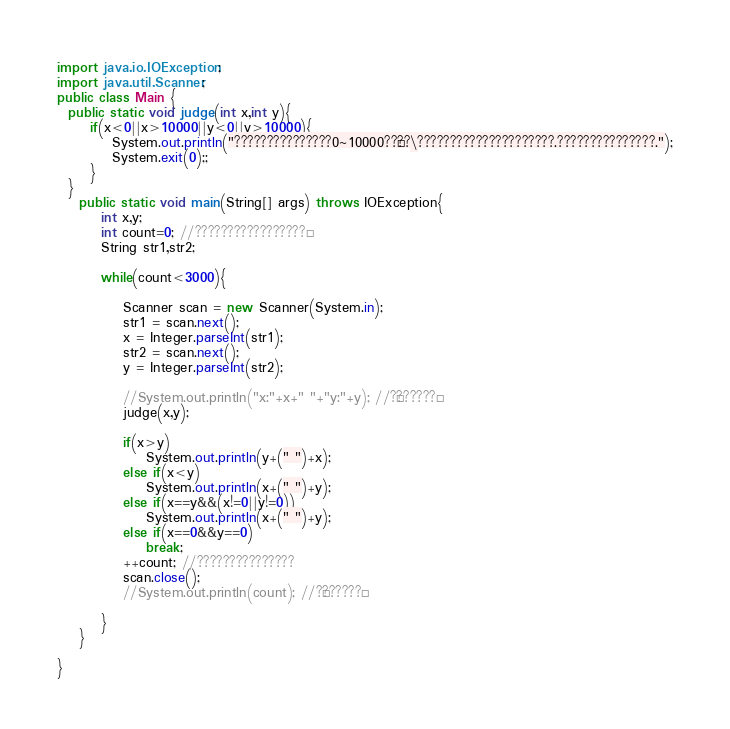Convert code to text. <code><loc_0><loc_0><loc_500><loc_500><_Java_>import java.io.IOException;
import java.util.Scanner;
public class Main {
  public static void judge(int x,int y){
	  if(x<0||x>10000||y<0||y>10000){
		  System.out.println("???????????????0~10000??§??\?????????????????????.???????????????.");
	      System.exit(0);;
	  }
  }
	public static void main(String[] args) throws IOException{
		int x,y;
		int count=0; //?????????????????°
		String str1,str2;

		while(count<3000){

			Scanner scan = new Scanner(System.in);
			str1 = scan.next();
			x = Integer.parseInt(str1);
			str2 = scan.next();
			y = Integer.parseInt(str2);

			//System.out.println("x:"+x+" "+"y:"+y); //?¢??????¨
			judge(x,y);

			if(x>y)
				System.out.println(y+(" ")+x);
			else if(x<y)
				System.out.println(x+(" ")+y);
			else if(x==y&&(x!=0||y!=0))
				System.out.println(x+(" ")+y);
			else if(x==0&&y==0)
				break;
			++count; //???????????????
			scan.close();
			//System.out.println(count); //?¢??????¨

		}
	}

}</code> 